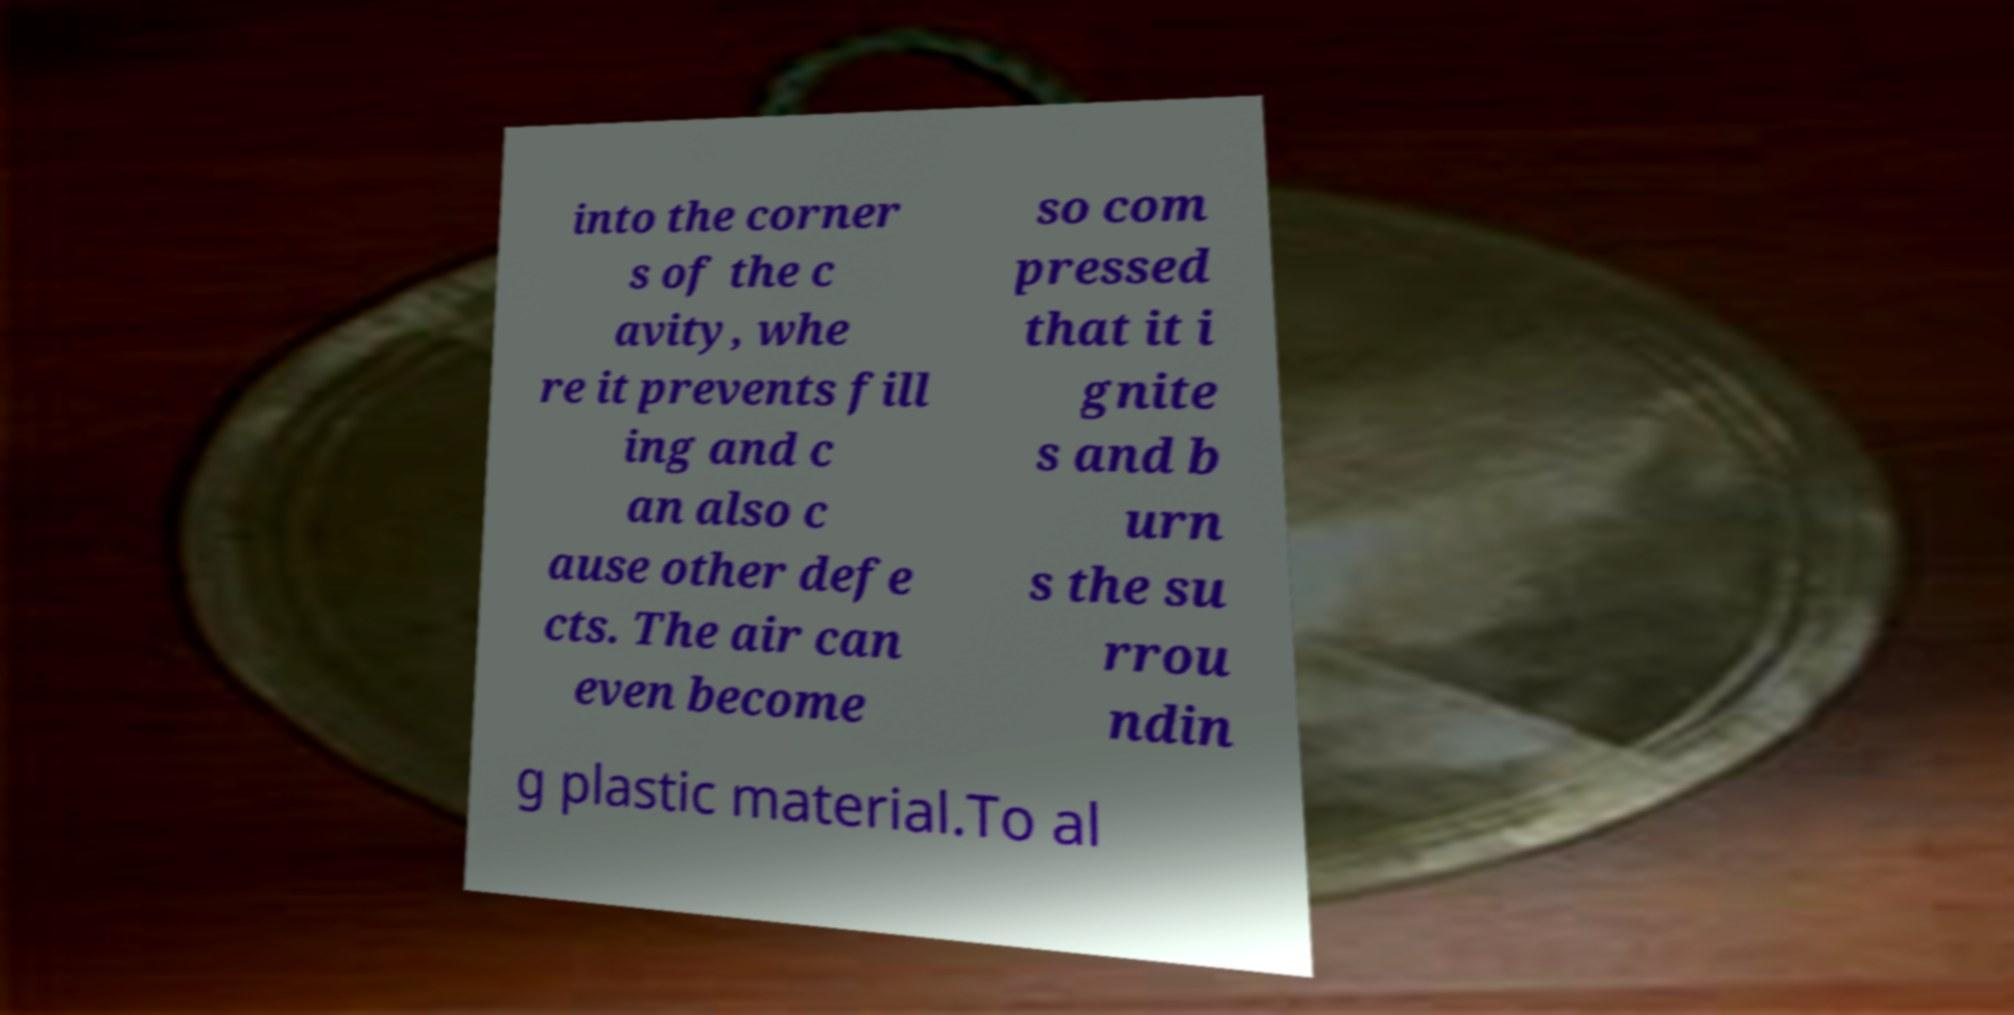I need the written content from this picture converted into text. Can you do that? into the corner s of the c avity, whe re it prevents fill ing and c an also c ause other defe cts. The air can even become so com pressed that it i gnite s and b urn s the su rrou ndin g plastic material.To al 